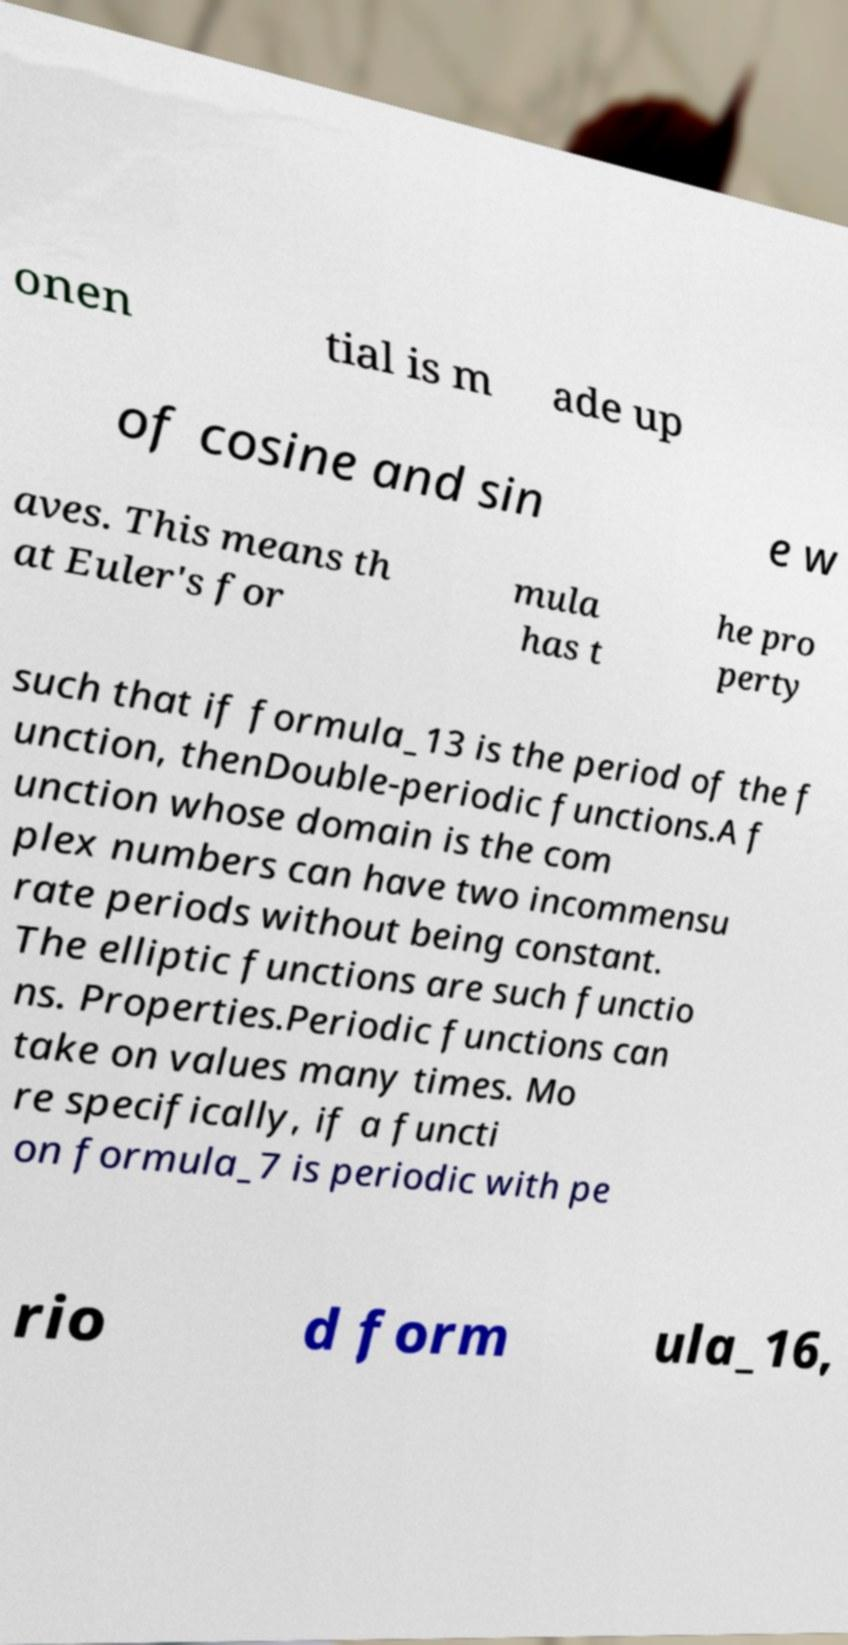Can you read and provide the text displayed in the image?This photo seems to have some interesting text. Can you extract and type it out for me? onen tial is m ade up of cosine and sin e w aves. This means th at Euler's for mula has t he pro perty such that if formula_13 is the period of the f unction, thenDouble-periodic functions.A f unction whose domain is the com plex numbers can have two incommensu rate periods without being constant. The elliptic functions are such functio ns. Properties.Periodic functions can take on values many times. Mo re specifically, if a functi on formula_7 is periodic with pe rio d form ula_16, 